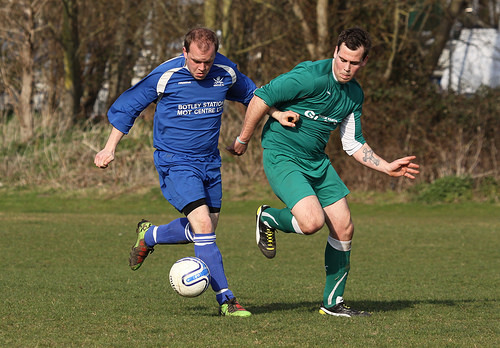<image>
Is the tree behind the man? Yes. From this viewpoint, the tree is positioned behind the man, with the man partially or fully occluding the tree. Is the ball behind the man? No. The ball is not behind the man. From this viewpoint, the ball appears to be positioned elsewhere in the scene. 